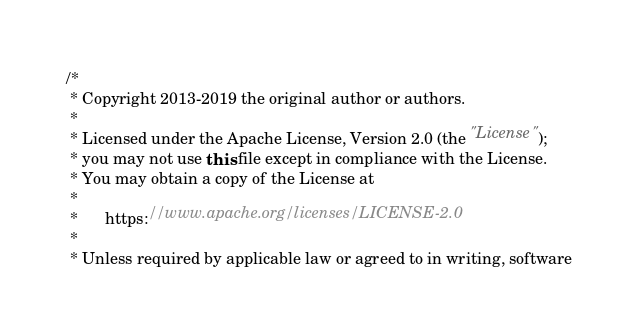<code> <loc_0><loc_0><loc_500><loc_500><_Java_>/*
 * Copyright 2013-2019 the original author or authors.
 *
 * Licensed under the Apache License, Version 2.0 (the "License");
 * you may not use this file except in compliance with the License.
 * You may obtain a copy of the License at
 *
 *      https://www.apache.org/licenses/LICENSE-2.0
 *
 * Unless required by applicable law or agreed to in writing, software</code> 